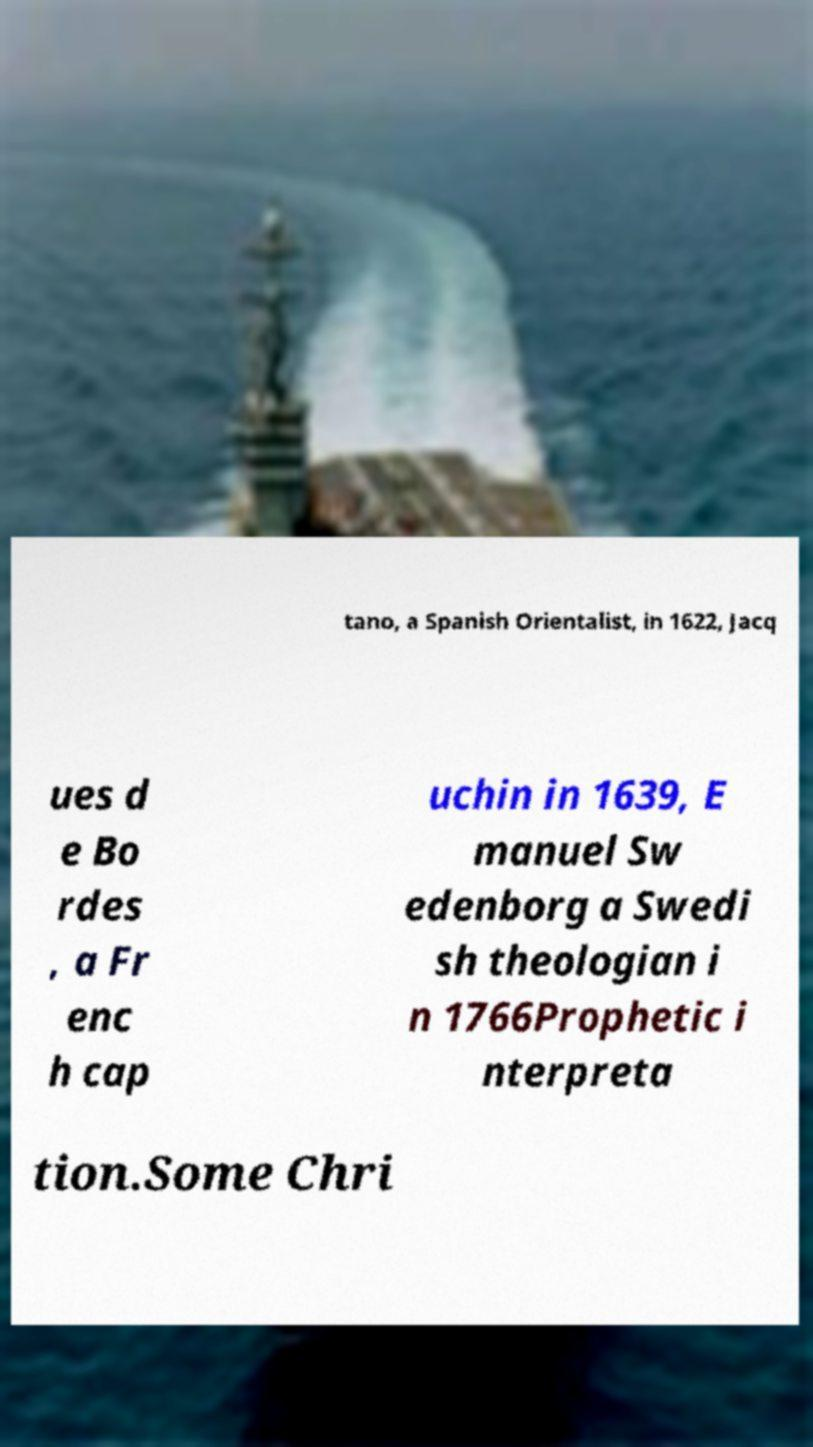Can you accurately transcribe the text from the provided image for me? tano, a Spanish Orientalist, in 1622, Jacq ues d e Bo rdes , a Fr enc h cap uchin in 1639, E manuel Sw edenborg a Swedi sh theologian i n 1766Prophetic i nterpreta tion.Some Chri 